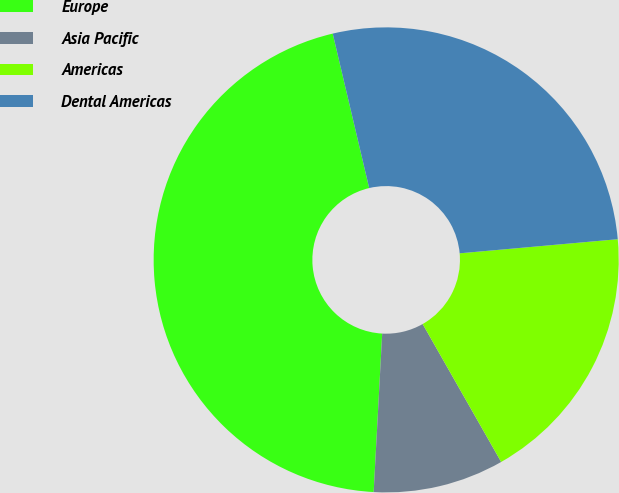<chart> <loc_0><loc_0><loc_500><loc_500><pie_chart><fcel>Europe<fcel>Asia Pacific<fcel>Americas<fcel>Dental Americas<nl><fcel>45.45%<fcel>9.09%<fcel>18.18%<fcel>27.27%<nl></chart> 